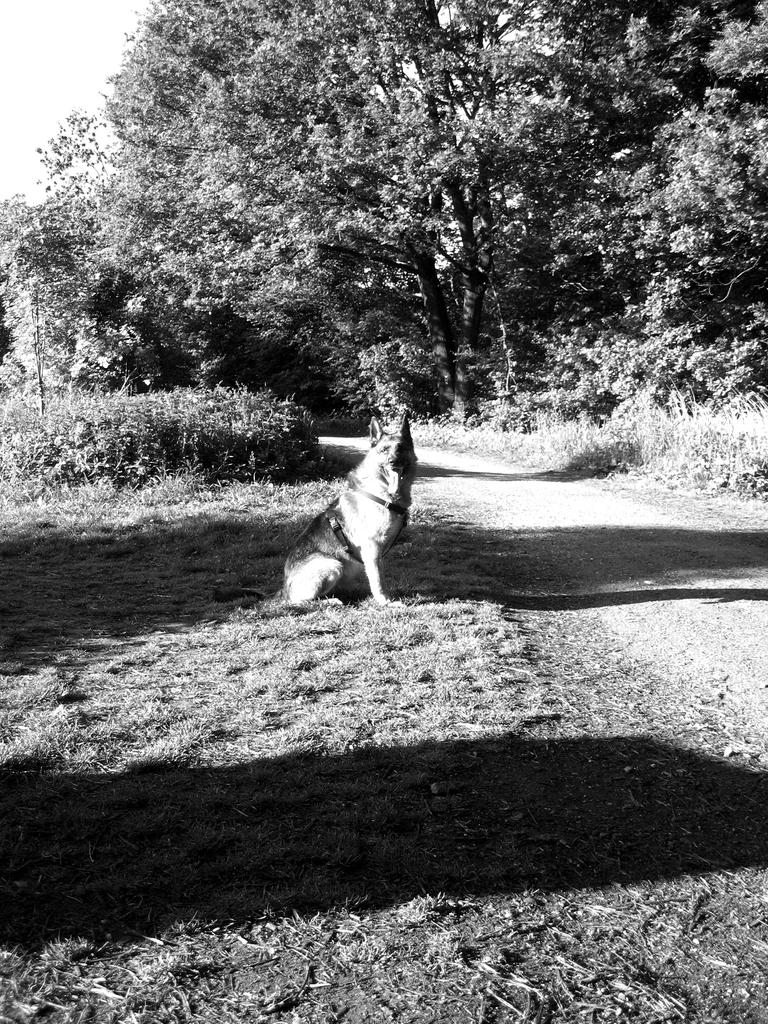What is the color scheme of the image? The image is black and white. What can be seen in the middle of the image? There is a road in the image. What type of vegetation is present on the sides of the road? There are trees and plants on the sides of the road. What animal is visible in the image? There is a dog in the image. What type of sweater is the dog wearing in the image? There is no sweater present on the dog in the image; it is not wearing any clothing. 